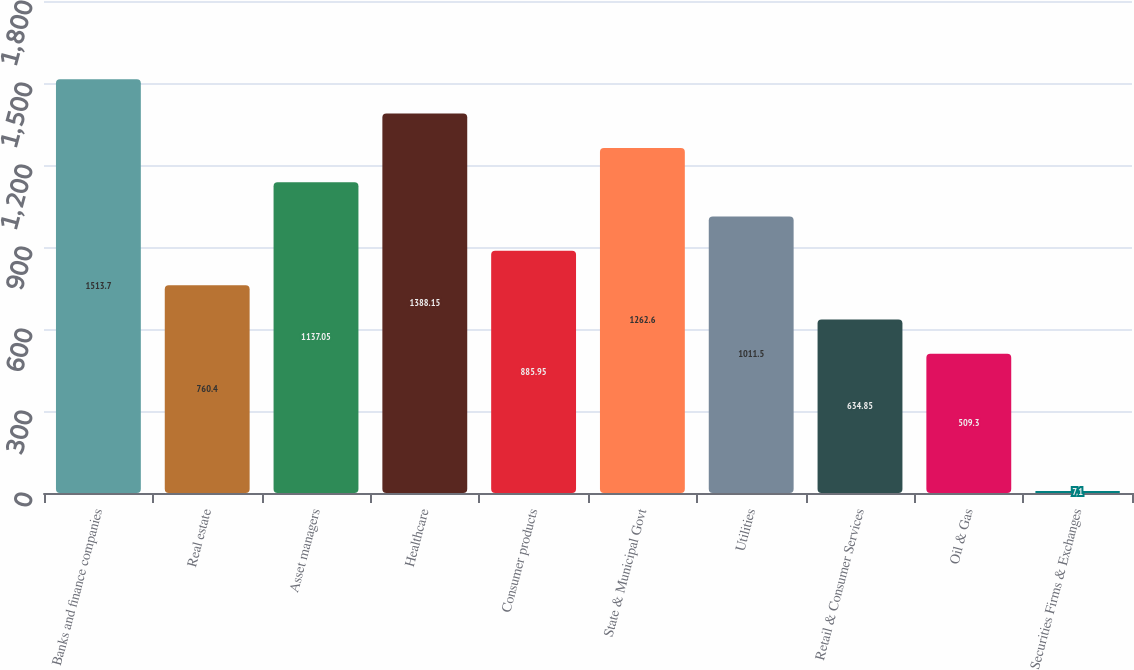Convert chart to OTSL. <chart><loc_0><loc_0><loc_500><loc_500><bar_chart><fcel>Banks and finance companies<fcel>Real estate<fcel>Asset managers<fcel>Healthcare<fcel>Consumer products<fcel>State & Municipal Govt<fcel>Utilities<fcel>Retail & Consumer Services<fcel>Oil & Gas<fcel>Securities Firms & Exchanges<nl><fcel>1513.7<fcel>760.4<fcel>1137.05<fcel>1388.15<fcel>885.95<fcel>1262.6<fcel>1011.5<fcel>634.85<fcel>509.3<fcel>7.1<nl></chart> 